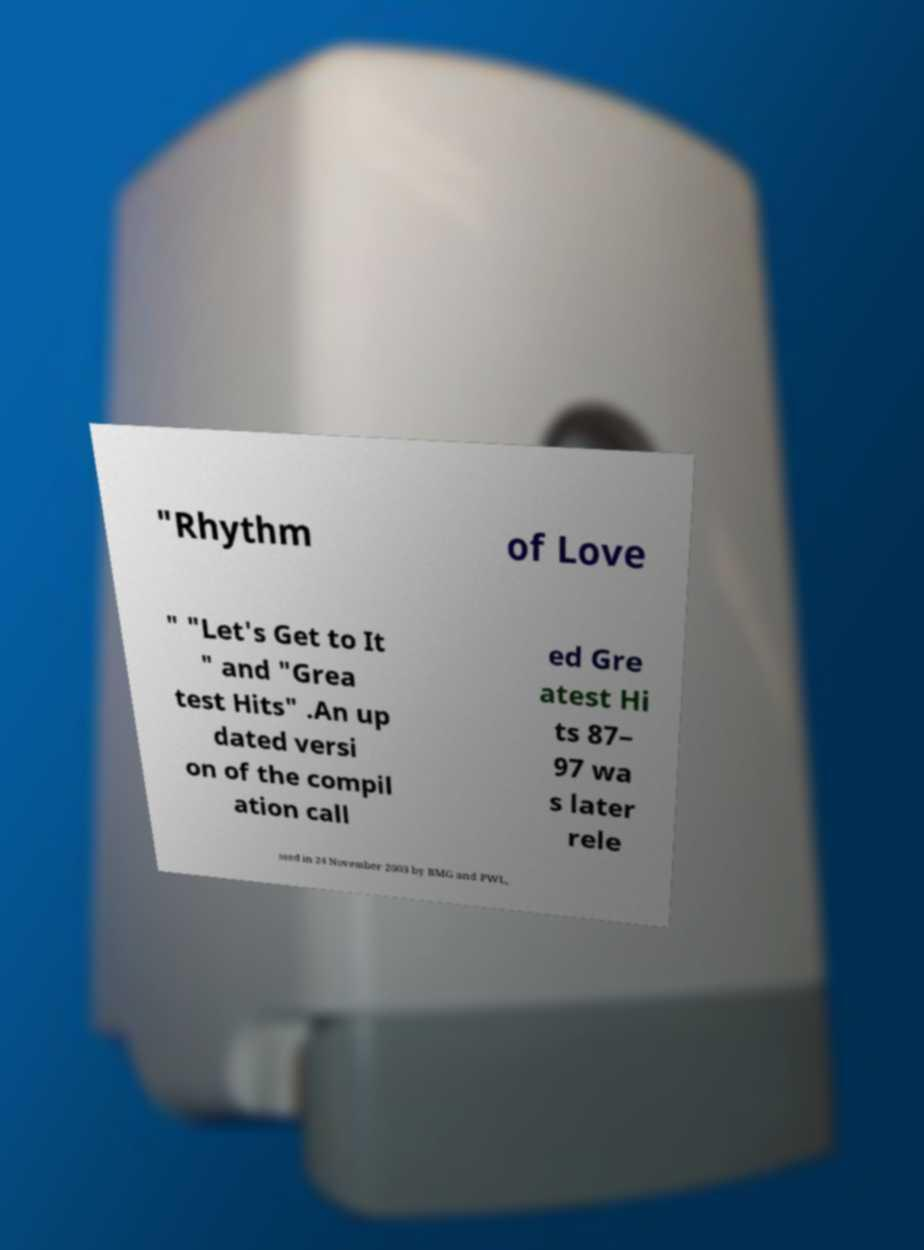What messages or text are displayed in this image? I need them in a readable, typed format. "Rhythm of Love " "Let's Get to It " and "Grea test Hits" .An up dated versi on of the compil ation call ed Gre atest Hi ts 87– 97 wa s later rele ased in 24 November 2003 by BMG and PWL, 